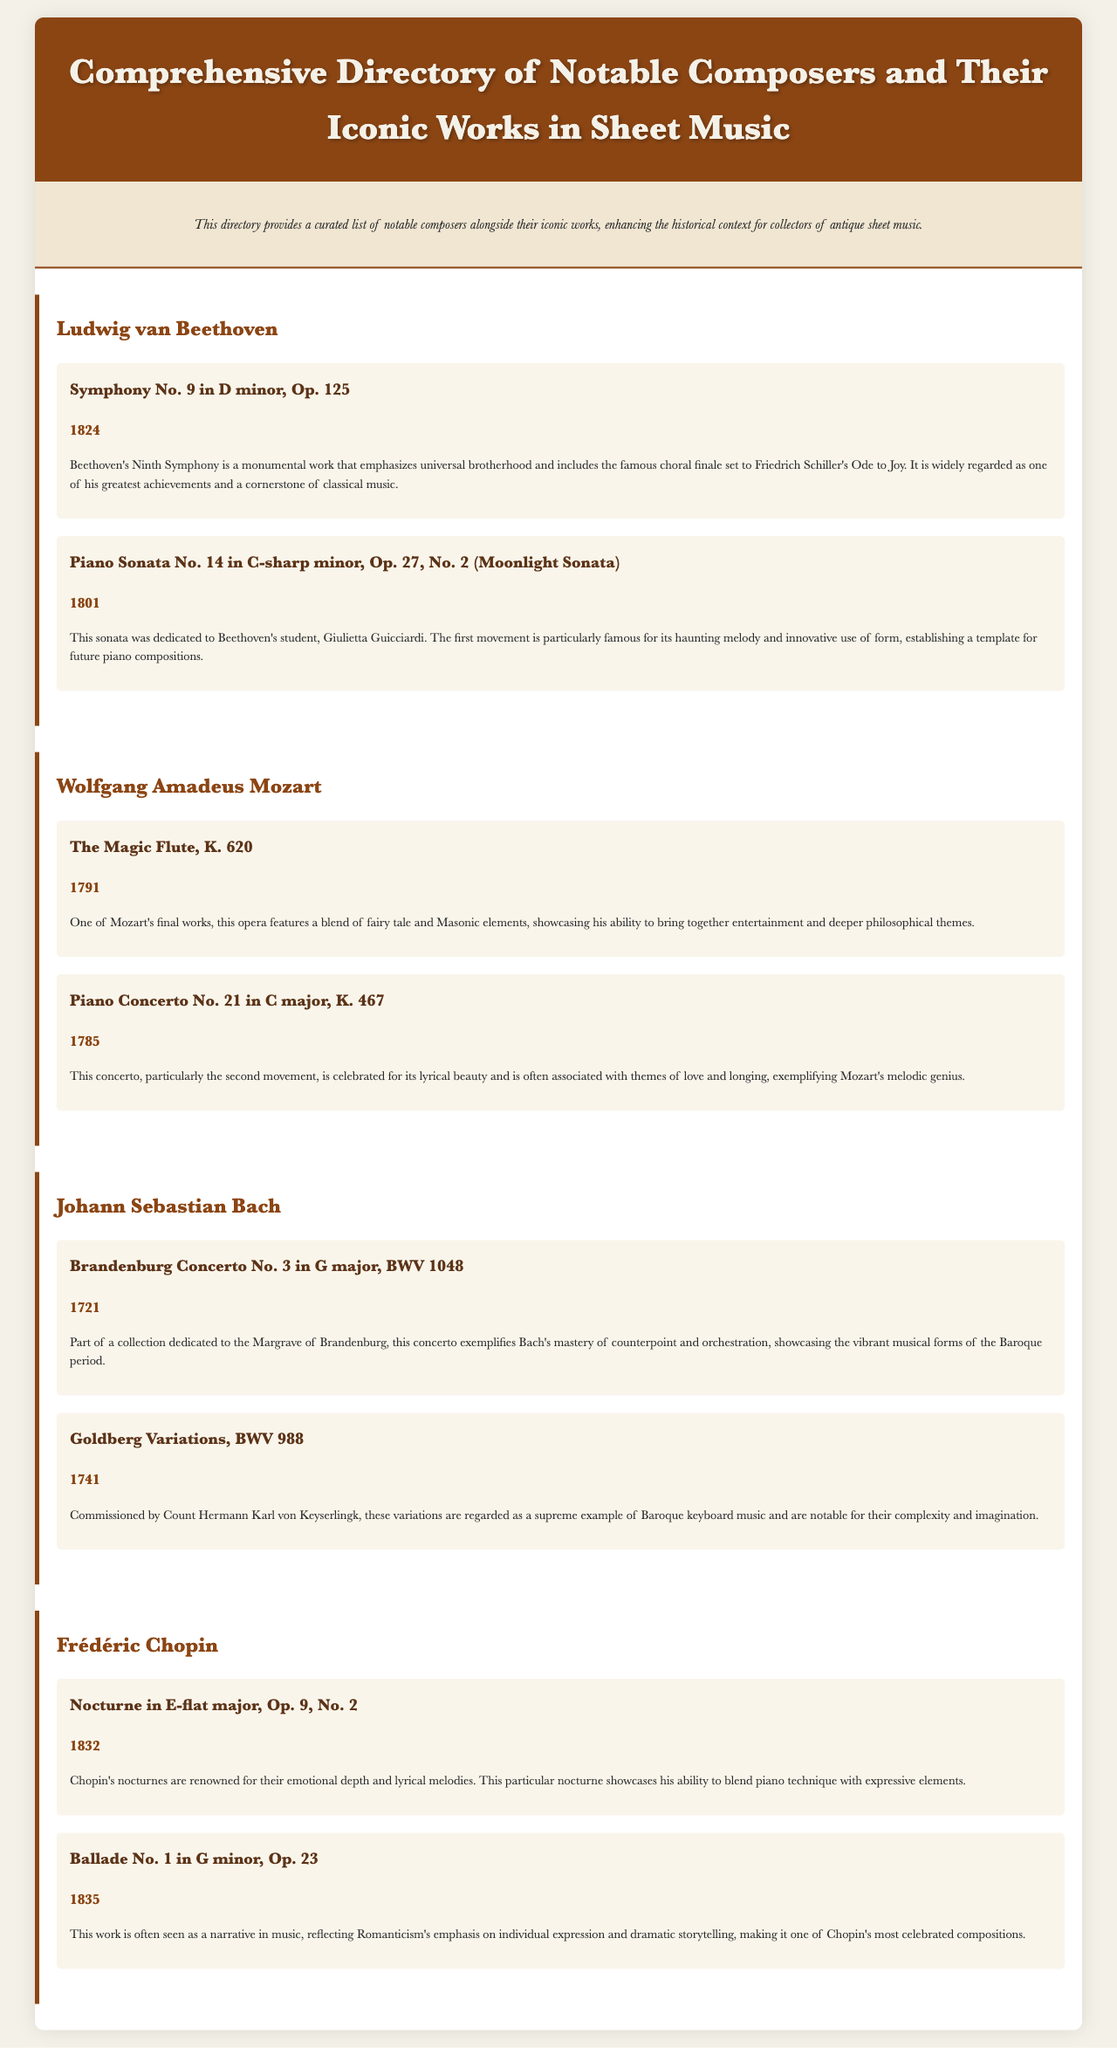What is the title of the directory? The title is stated in the header of the document.
Answer: Comprehensive Directory of Notable Composers and Their Iconic Works in Sheet Music Who composed the Moonlight Sonata? The document lists Beethoven as the composer of this work.
Answer: Ludwig van Beethoven In what year was The Magic Flute composed? The year of composition is mentioned alongside the title in the document.
Answer: 1791 Which work by Bach is part of the Brandenburg Concertos? This work is explicitly identified in the section about Bach.
Answer: Brandenburg Concerto No. 3 in G major, BWV 1048 How many works are listed for Chopin in the document? The number of works can be counted from Chopin's section.
Answer: 2 What theme does Beethoven's Ninth Symphony emphasize? The document describes the theme of universal brotherhood specifically.
Answer: Universal brotherhood Which composer's works feature a blend of fairy tale and Masonic elements? The document provides a context for Mozart's work related to these themes.
Answer: Wolfgang Amadeus Mozart What does the context of Chopin's Ballade No. 1 emphasize? The context describes the work's relationship with Romanticism and individual expression.
Answer: Individual expression and dramatic storytelling 